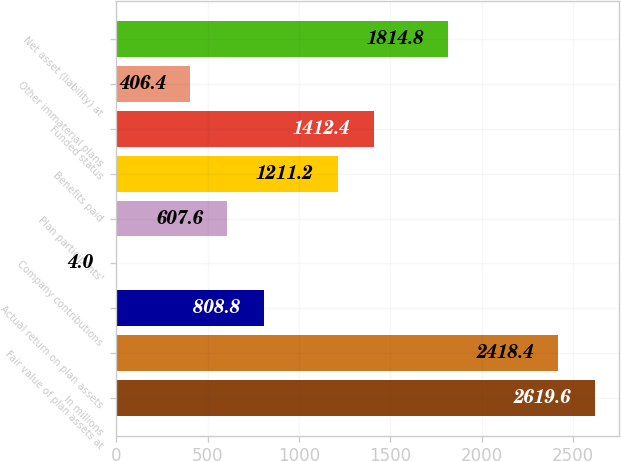Convert chart to OTSL. <chart><loc_0><loc_0><loc_500><loc_500><bar_chart><fcel>In millions<fcel>Fair value of plan assets at<fcel>Actual return on plan assets<fcel>Company contributions<fcel>Plan participants'<fcel>Benefits paid<fcel>Funded status<fcel>Other immaterial plans<fcel>Net asset (liability) at<nl><fcel>2619.6<fcel>2418.4<fcel>808.8<fcel>4<fcel>607.6<fcel>1211.2<fcel>1412.4<fcel>406.4<fcel>1814.8<nl></chart> 